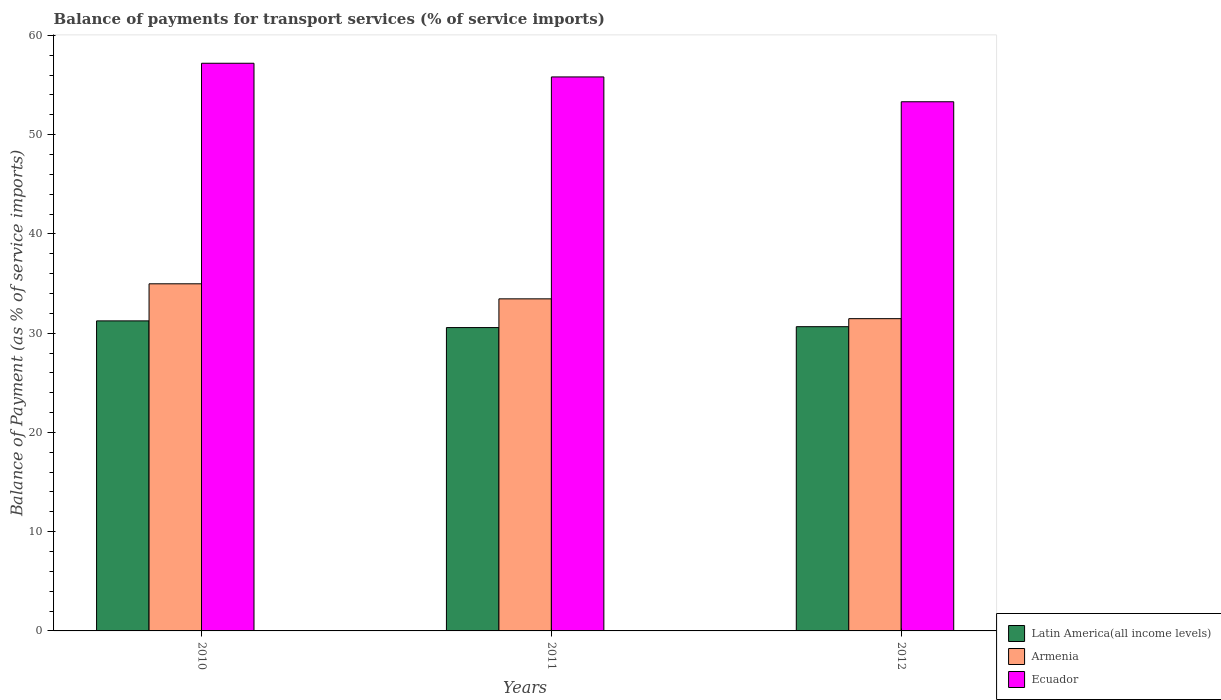Are the number of bars per tick equal to the number of legend labels?
Make the answer very short. Yes. Are the number of bars on each tick of the X-axis equal?
Offer a terse response. Yes. How many bars are there on the 1st tick from the left?
Your answer should be compact. 3. What is the label of the 2nd group of bars from the left?
Provide a short and direct response. 2011. In how many cases, is the number of bars for a given year not equal to the number of legend labels?
Your response must be concise. 0. What is the balance of payments for transport services in Latin America(all income levels) in 2012?
Ensure brevity in your answer.  30.65. Across all years, what is the maximum balance of payments for transport services in Ecuador?
Your answer should be compact. 57.19. Across all years, what is the minimum balance of payments for transport services in Ecuador?
Your answer should be compact. 53.31. In which year was the balance of payments for transport services in Armenia maximum?
Your answer should be very brief. 2010. What is the total balance of payments for transport services in Latin America(all income levels) in the graph?
Give a very brief answer. 92.45. What is the difference between the balance of payments for transport services in Armenia in 2010 and that in 2011?
Keep it short and to the point. 1.52. What is the difference between the balance of payments for transport services in Latin America(all income levels) in 2011 and the balance of payments for transport services in Ecuador in 2010?
Offer a very short reply. -26.63. What is the average balance of payments for transport services in Ecuador per year?
Provide a succinct answer. 55.44. In the year 2011, what is the difference between the balance of payments for transport services in Armenia and balance of payments for transport services in Latin America(all income levels)?
Your answer should be compact. 2.89. In how many years, is the balance of payments for transport services in Latin America(all income levels) greater than 8 %?
Your answer should be very brief. 3. What is the ratio of the balance of payments for transport services in Armenia in 2011 to that in 2012?
Ensure brevity in your answer.  1.06. What is the difference between the highest and the second highest balance of payments for transport services in Ecuador?
Offer a terse response. 1.38. What is the difference between the highest and the lowest balance of payments for transport services in Ecuador?
Offer a terse response. 3.88. What does the 1st bar from the left in 2010 represents?
Keep it short and to the point. Latin America(all income levels). What does the 3rd bar from the right in 2010 represents?
Make the answer very short. Latin America(all income levels). Does the graph contain any zero values?
Provide a short and direct response. No. Does the graph contain grids?
Provide a short and direct response. No. How many legend labels are there?
Give a very brief answer. 3. What is the title of the graph?
Keep it short and to the point. Balance of payments for transport services (% of service imports). What is the label or title of the Y-axis?
Your answer should be compact. Balance of Payment (as % of service imports). What is the Balance of Payment (as % of service imports) in Latin America(all income levels) in 2010?
Make the answer very short. 31.24. What is the Balance of Payment (as % of service imports) in Armenia in 2010?
Your answer should be very brief. 34.97. What is the Balance of Payment (as % of service imports) in Ecuador in 2010?
Ensure brevity in your answer.  57.19. What is the Balance of Payment (as % of service imports) in Latin America(all income levels) in 2011?
Your answer should be compact. 30.56. What is the Balance of Payment (as % of service imports) of Armenia in 2011?
Offer a very short reply. 33.46. What is the Balance of Payment (as % of service imports) of Ecuador in 2011?
Make the answer very short. 55.82. What is the Balance of Payment (as % of service imports) in Latin America(all income levels) in 2012?
Keep it short and to the point. 30.65. What is the Balance of Payment (as % of service imports) of Armenia in 2012?
Your answer should be very brief. 31.46. What is the Balance of Payment (as % of service imports) in Ecuador in 2012?
Ensure brevity in your answer.  53.31. Across all years, what is the maximum Balance of Payment (as % of service imports) in Latin America(all income levels)?
Your answer should be compact. 31.24. Across all years, what is the maximum Balance of Payment (as % of service imports) in Armenia?
Make the answer very short. 34.97. Across all years, what is the maximum Balance of Payment (as % of service imports) in Ecuador?
Your answer should be compact. 57.19. Across all years, what is the minimum Balance of Payment (as % of service imports) of Latin America(all income levels)?
Your answer should be very brief. 30.56. Across all years, what is the minimum Balance of Payment (as % of service imports) of Armenia?
Give a very brief answer. 31.46. Across all years, what is the minimum Balance of Payment (as % of service imports) in Ecuador?
Your answer should be very brief. 53.31. What is the total Balance of Payment (as % of service imports) of Latin America(all income levels) in the graph?
Offer a very short reply. 92.45. What is the total Balance of Payment (as % of service imports) of Armenia in the graph?
Your answer should be compact. 99.89. What is the total Balance of Payment (as % of service imports) of Ecuador in the graph?
Keep it short and to the point. 166.32. What is the difference between the Balance of Payment (as % of service imports) in Latin America(all income levels) in 2010 and that in 2011?
Your answer should be very brief. 0.67. What is the difference between the Balance of Payment (as % of service imports) of Armenia in 2010 and that in 2011?
Make the answer very short. 1.52. What is the difference between the Balance of Payment (as % of service imports) of Ecuador in 2010 and that in 2011?
Offer a terse response. 1.38. What is the difference between the Balance of Payment (as % of service imports) of Latin America(all income levels) in 2010 and that in 2012?
Make the answer very short. 0.58. What is the difference between the Balance of Payment (as % of service imports) in Armenia in 2010 and that in 2012?
Ensure brevity in your answer.  3.51. What is the difference between the Balance of Payment (as % of service imports) of Ecuador in 2010 and that in 2012?
Provide a short and direct response. 3.88. What is the difference between the Balance of Payment (as % of service imports) in Latin America(all income levels) in 2011 and that in 2012?
Your answer should be compact. -0.09. What is the difference between the Balance of Payment (as % of service imports) in Armenia in 2011 and that in 2012?
Your answer should be compact. 2. What is the difference between the Balance of Payment (as % of service imports) in Ecuador in 2011 and that in 2012?
Give a very brief answer. 2.5. What is the difference between the Balance of Payment (as % of service imports) of Latin America(all income levels) in 2010 and the Balance of Payment (as % of service imports) of Armenia in 2011?
Your response must be concise. -2.22. What is the difference between the Balance of Payment (as % of service imports) of Latin America(all income levels) in 2010 and the Balance of Payment (as % of service imports) of Ecuador in 2011?
Keep it short and to the point. -24.58. What is the difference between the Balance of Payment (as % of service imports) in Armenia in 2010 and the Balance of Payment (as % of service imports) in Ecuador in 2011?
Your answer should be compact. -20.84. What is the difference between the Balance of Payment (as % of service imports) in Latin America(all income levels) in 2010 and the Balance of Payment (as % of service imports) in Armenia in 2012?
Your response must be concise. -0.22. What is the difference between the Balance of Payment (as % of service imports) of Latin America(all income levels) in 2010 and the Balance of Payment (as % of service imports) of Ecuador in 2012?
Your answer should be very brief. -22.08. What is the difference between the Balance of Payment (as % of service imports) of Armenia in 2010 and the Balance of Payment (as % of service imports) of Ecuador in 2012?
Offer a very short reply. -18.34. What is the difference between the Balance of Payment (as % of service imports) of Latin America(all income levels) in 2011 and the Balance of Payment (as % of service imports) of Armenia in 2012?
Ensure brevity in your answer.  -0.9. What is the difference between the Balance of Payment (as % of service imports) of Latin America(all income levels) in 2011 and the Balance of Payment (as % of service imports) of Ecuador in 2012?
Offer a terse response. -22.75. What is the difference between the Balance of Payment (as % of service imports) in Armenia in 2011 and the Balance of Payment (as % of service imports) in Ecuador in 2012?
Keep it short and to the point. -19.86. What is the average Balance of Payment (as % of service imports) in Latin America(all income levels) per year?
Provide a succinct answer. 30.82. What is the average Balance of Payment (as % of service imports) in Armenia per year?
Offer a terse response. 33.3. What is the average Balance of Payment (as % of service imports) in Ecuador per year?
Provide a succinct answer. 55.44. In the year 2010, what is the difference between the Balance of Payment (as % of service imports) in Latin America(all income levels) and Balance of Payment (as % of service imports) in Armenia?
Make the answer very short. -3.74. In the year 2010, what is the difference between the Balance of Payment (as % of service imports) of Latin America(all income levels) and Balance of Payment (as % of service imports) of Ecuador?
Your response must be concise. -25.96. In the year 2010, what is the difference between the Balance of Payment (as % of service imports) in Armenia and Balance of Payment (as % of service imports) in Ecuador?
Your answer should be compact. -22.22. In the year 2011, what is the difference between the Balance of Payment (as % of service imports) of Latin America(all income levels) and Balance of Payment (as % of service imports) of Armenia?
Provide a short and direct response. -2.89. In the year 2011, what is the difference between the Balance of Payment (as % of service imports) of Latin America(all income levels) and Balance of Payment (as % of service imports) of Ecuador?
Keep it short and to the point. -25.25. In the year 2011, what is the difference between the Balance of Payment (as % of service imports) in Armenia and Balance of Payment (as % of service imports) in Ecuador?
Your answer should be compact. -22.36. In the year 2012, what is the difference between the Balance of Payment (as % of service imports) in Latin America(all income levels) and Balance of Payment (as % of service imports) in Armenia?
Offer a terse response. -0.81. In the year 2012, what is the difference between the Balance of Payment (as % of service imports) in Latin America(all income levels) and Balance of Payment (as % of service imports) in Ecuador?
Keep it short and to the point. -22.66. In the year 2012, what is the difference between the Balance of Payment (as % of service imports) of Armenia and Balance of Payment (as % of service imports) of Ecuador?
Keep it short and to the point. -21.86. What is the ratio of the Balance of Payment (as % of service imports) of Latin America(all income levels) in 2010 to that in 2011?
Make the answer very short. 1.02. What is the ratio of the Balance of Payment (as % of service imports) in Armenia in 2010 to that in 2011?
Offer a terse response. 1.05. What is the ratio of the Balance of Payment (as % of service imports) of Ecuador in 2010 to that in 2011?
Your answer should be compact. 1.02. What is the ratio of the Balance of Payment (as % of service imports) in Latin America(all income levels) in 2010 to that in 2012?
Your answer should be compact. 1.02. What is the ratio of the Balance of Payment (as % of service imports) of Armenia in 2010 to that in 2012?
Your response must be concise. 1.11. What is the ratio of the Balance of Payment (as % of service imports) of Ecuador in 2010 to that in 2012?
Your answer should be compact. 1.07. What is the ratio of the Balance of Payment (as % of service imports) in Armenia in 2011 to that in 2012?
Provide a succinct answer. 1.06. What is the ratio of the Balance of Payment (as % of service imports) in Ecuador in 2011 to that in 2012?
Make the answer very short. 1.05. What is the difference between the highest and the second highest Balance of Payment (as % of service imports) in Latin America(all income levels)?
Your answer should be very brief. 0.58. What is the difference between the highest and the second highest Balance of Payment (as % of service imports) in Armenia?
Your answer should be compact. 1.52. What is the difference between the highest and the second highest Balance of Payment (as % of service imports) of Ecuador?
Make the answer very short. 1.38. What is the difference between the highest and the lowest Balance of Payment (as % of service imports) of Latin America(all income levels)?
Provide a short and direct response. 0.67. What is the difference between the highest and the lowest Balance of Payment (as % of service imports) of Armenia?
Make the answer very short. 3.51. What is the difference between the highest and the lowest Balance of Payment (as % of service imports) in Ecuador?
Your answer should be compact. 3.88. 